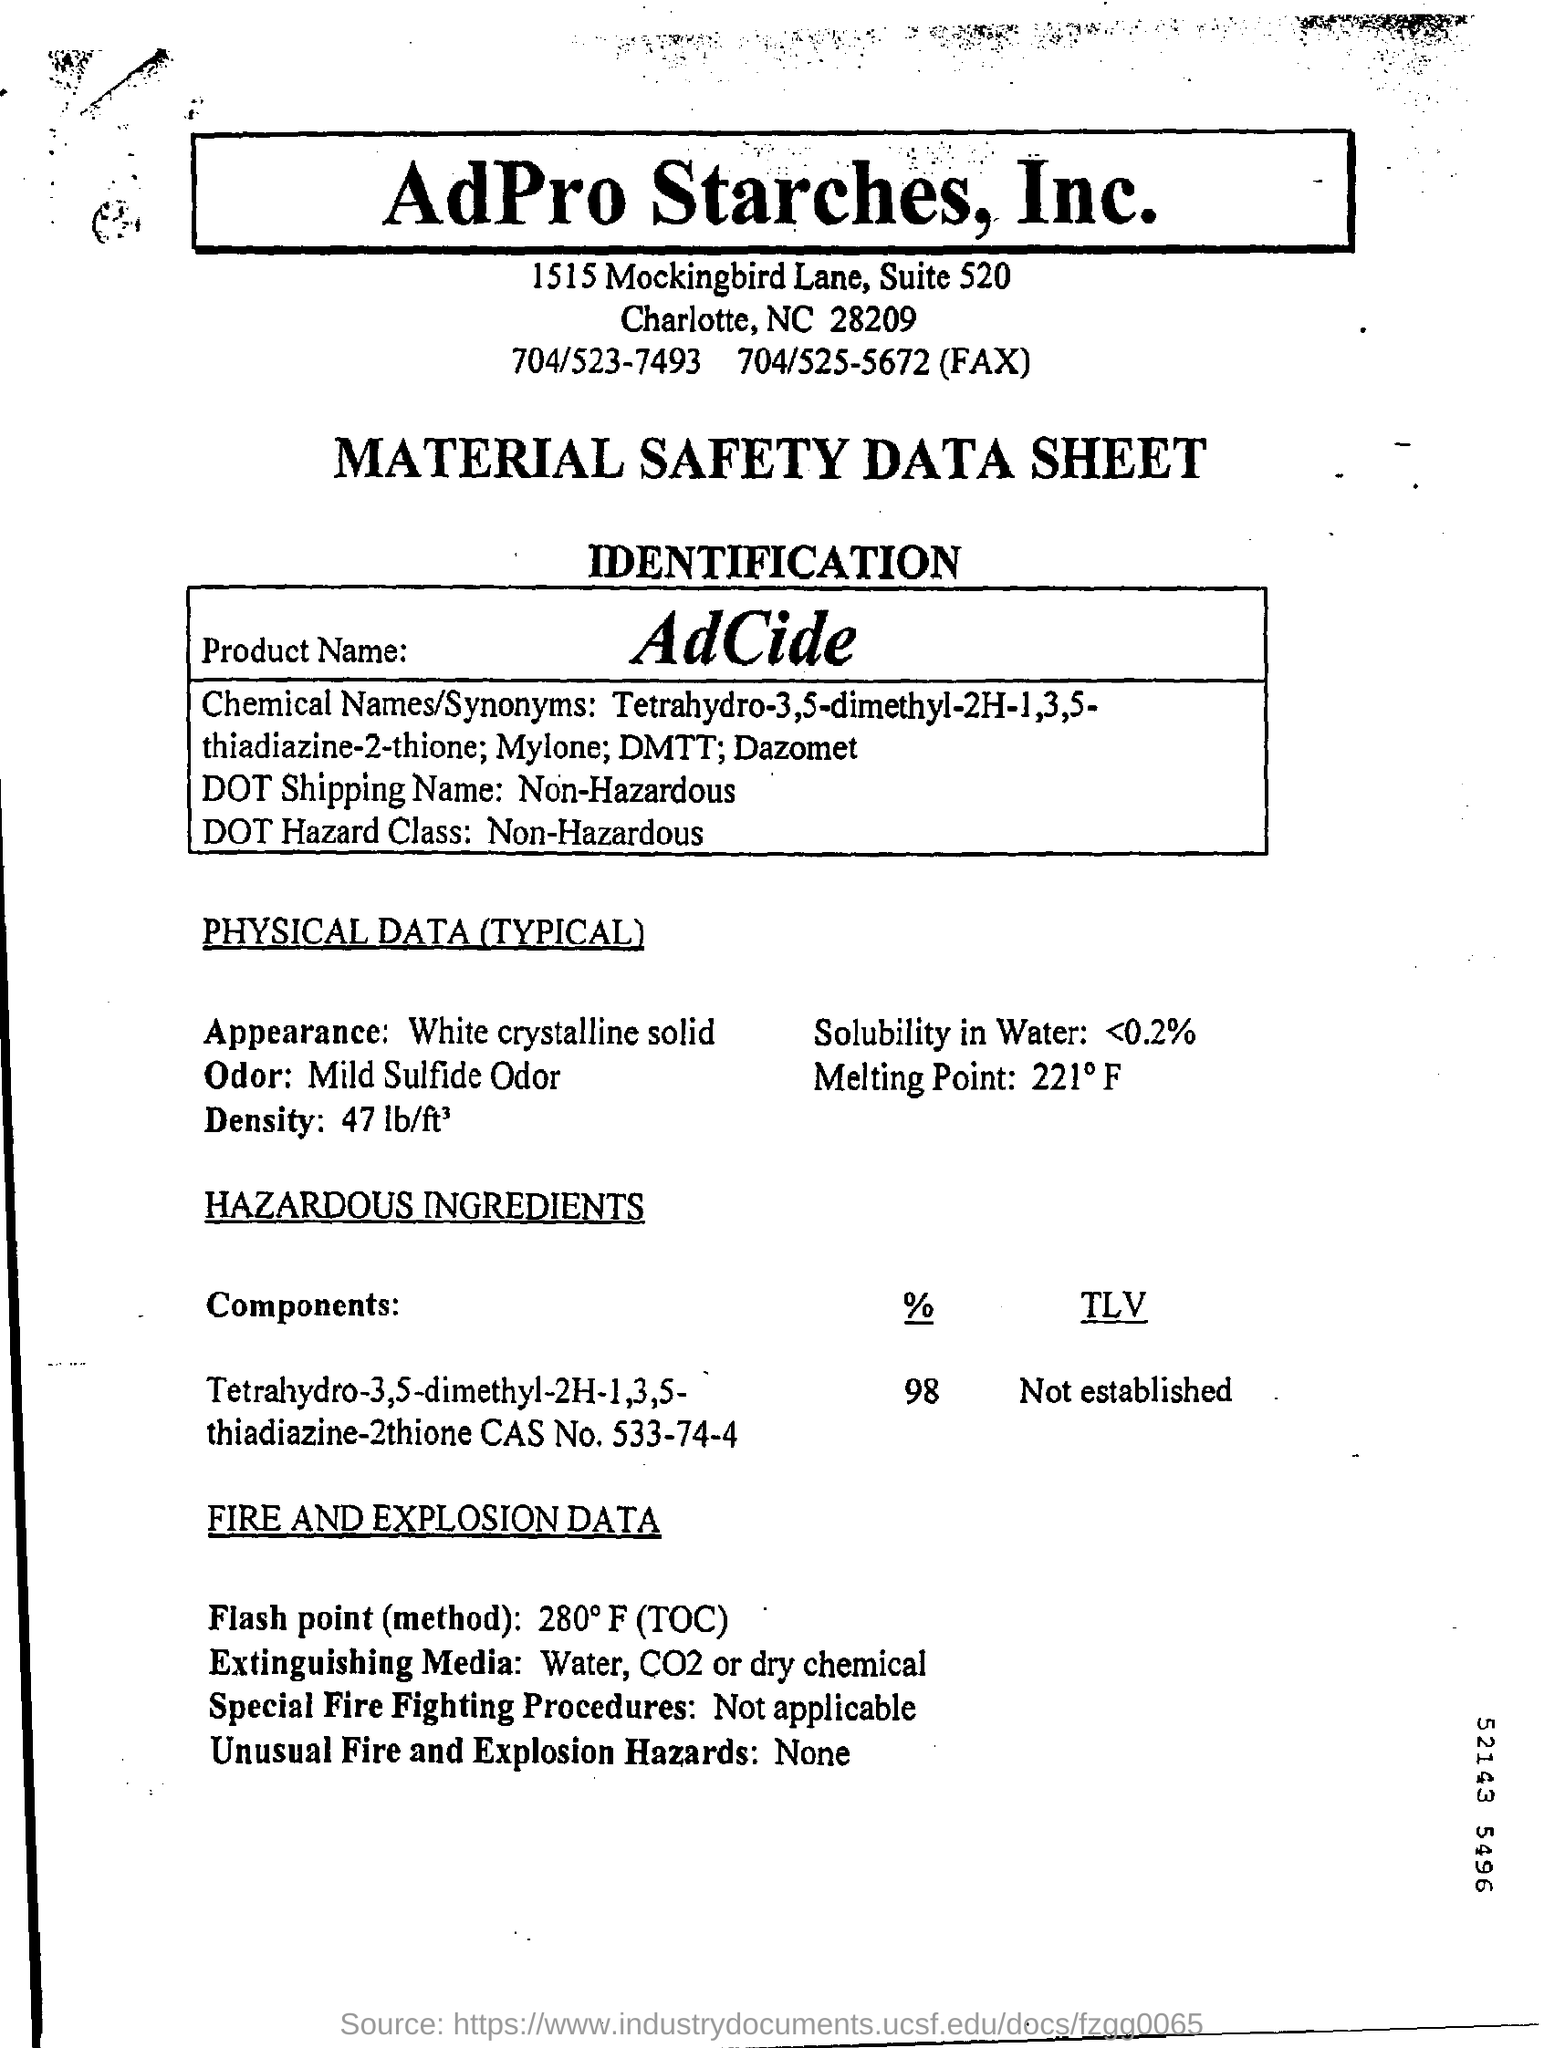What is the Product Name?
Your answer should be compact. AdCide. What is the DOT Shipping Name?
Your answer should be very brief. Non-Hazardous. What is DOT Hazard Class?
Keep it short and to the point. Non-Hazardous. What is the Appearance?
Keep it short and to the point. White crystalline solid. What is the Solubility in water?
Your answer should be very brief. <0.2%. 